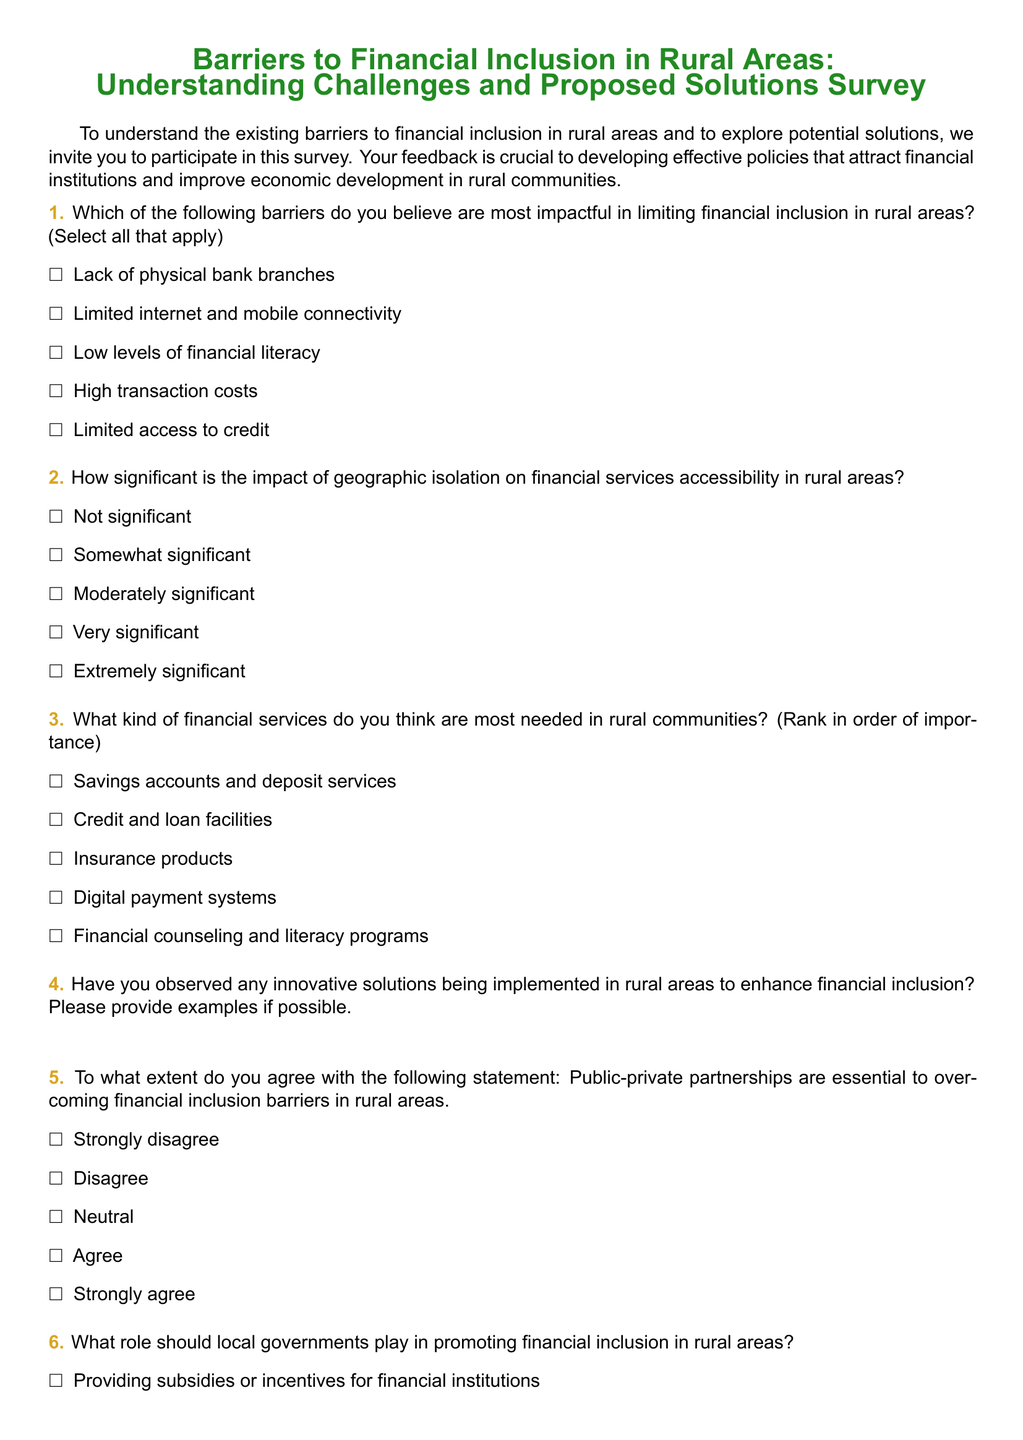What is the title of the survey? The title of the survey is explicitly stated at the beginning of the document.
Answer: Barriers to Financial Inclusion in Rural Areas: Understanding Challenges and Proposed Solutions Survey How many barriers can respondents select in question 1? The question specifies that respondents can select all that apply.
Answer: All that apply What is the first financial service listed as needed in rural communities? The services are listed in a specific order, with the first one being mentioned clearly.
Answer: Savings accounts and deposit services What rating scale is used for question 2 regarding geographic isolation? The scale includes various levels of significance to be indicated by the respondents.
Answer: Not significant to Extremely significant What kind of partnerships does question 5 emphasize? The question specifically mentions a type of partnership that is believed to be essential for overcoming barriers.
Answer: Public-private partnerships What is one proposed role for local governments in question 6? The choices given include several roles which local governments might play, one of which is indicated in the options.
Answer: Providing subsidies or incentives for financial institutions What are the challenges mentioned in question 8 faced by financial institutions? The challenges are listed as options for the participants to choose from.
Answer: High operational costs How many options are provided for the barriers in question 1? The number of options is an important detail that can directly be counted from the document.
Answer: Five What is the final note in the document about participating in the survey? The final note wraps up the survey's purpose and intent, summarizing its value.
Answer: Your insights are valuable for our efforts to enhance financial inclusion in rural areas and drive economic development 